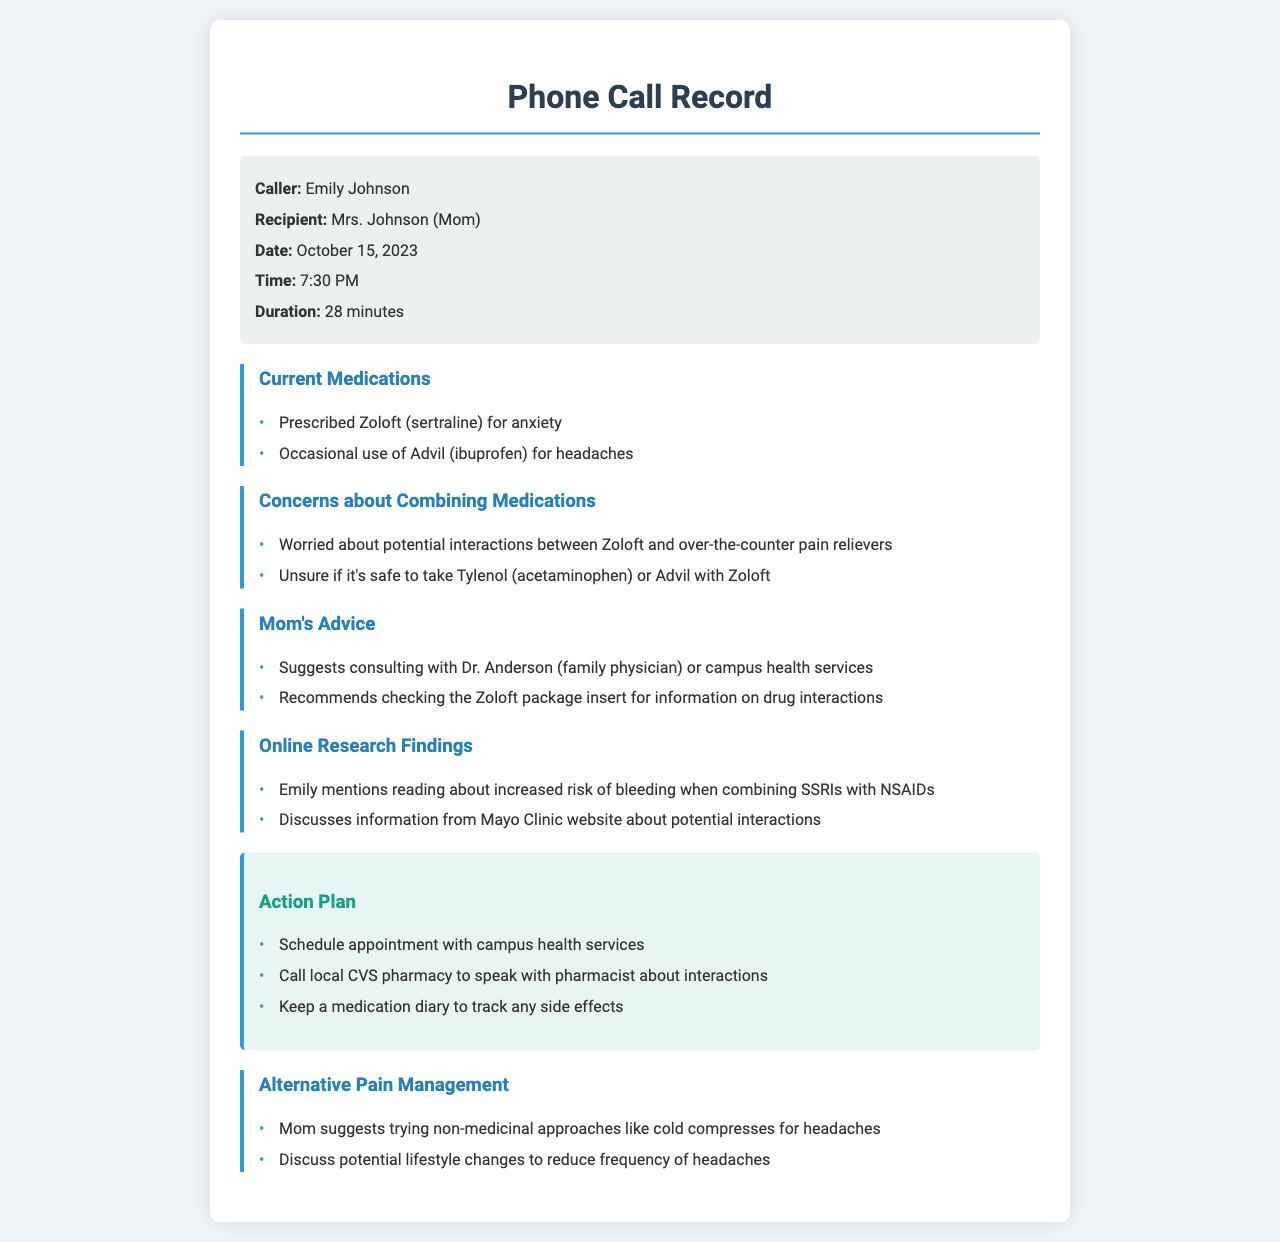what medication is prescribed for anxiety? The document states that Emily is prescribed Zoloft (sertraline) for anxiety.
Answer: Zoloft (sertraline) what over-the-counter pain reliever does Emily occasionally use? The document mentions that Emily occasionally uses Advil (ibuprofen) for headaches.
Answer: Advil (ibuprofen) who does Mom suggest consulting for medication concerns? The document indicates that Mom suggests consulting with Dr. Anderson (family physician) or campus health services.
Answer: Dr. Anderson what is a potential risk when combining SSRIs with NSAIDs? The conversation mentions an increased risk of bleeding when combining SSRIs with NSAIDs.
Answer: increased risk of bleeding what should Emily do to track any side effects? The action plan states that Emily should keep a medication diary to track any side effects.
Answer: keep a medication diary how long did the phone call last? The document specifies that the duration of the phone call was 28 minutes.
Answer: 28 minutes what alternative approach does Mom suggest for headache management? The document indicates that Mom suggests trying non-medicinal approaches like cold compresses for headaches.
Answer: cold compresses what was discussed regarding lifestyle changes? The document summarizes a discussion on potential lifestyle changes to reduce the frequency of headaches.
Answer: potential lifestyle changes 